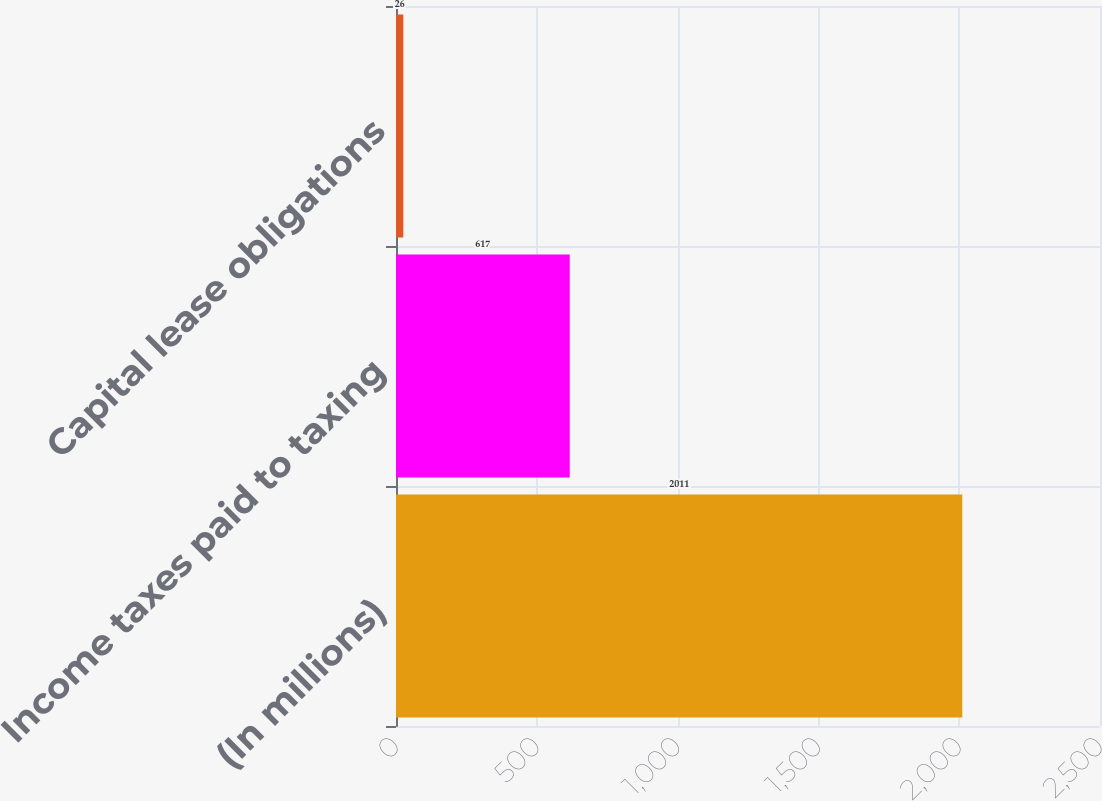Convert chart. <chart><loc_0><loc_0><loc_500><loc_500><bar_chart><fcel>(In millions)<fcel>Income taxes paid to taxing<fcel>Capital lease obligations<nl><fcel>2011<fcel>617<fcel>26<nl></chart> 